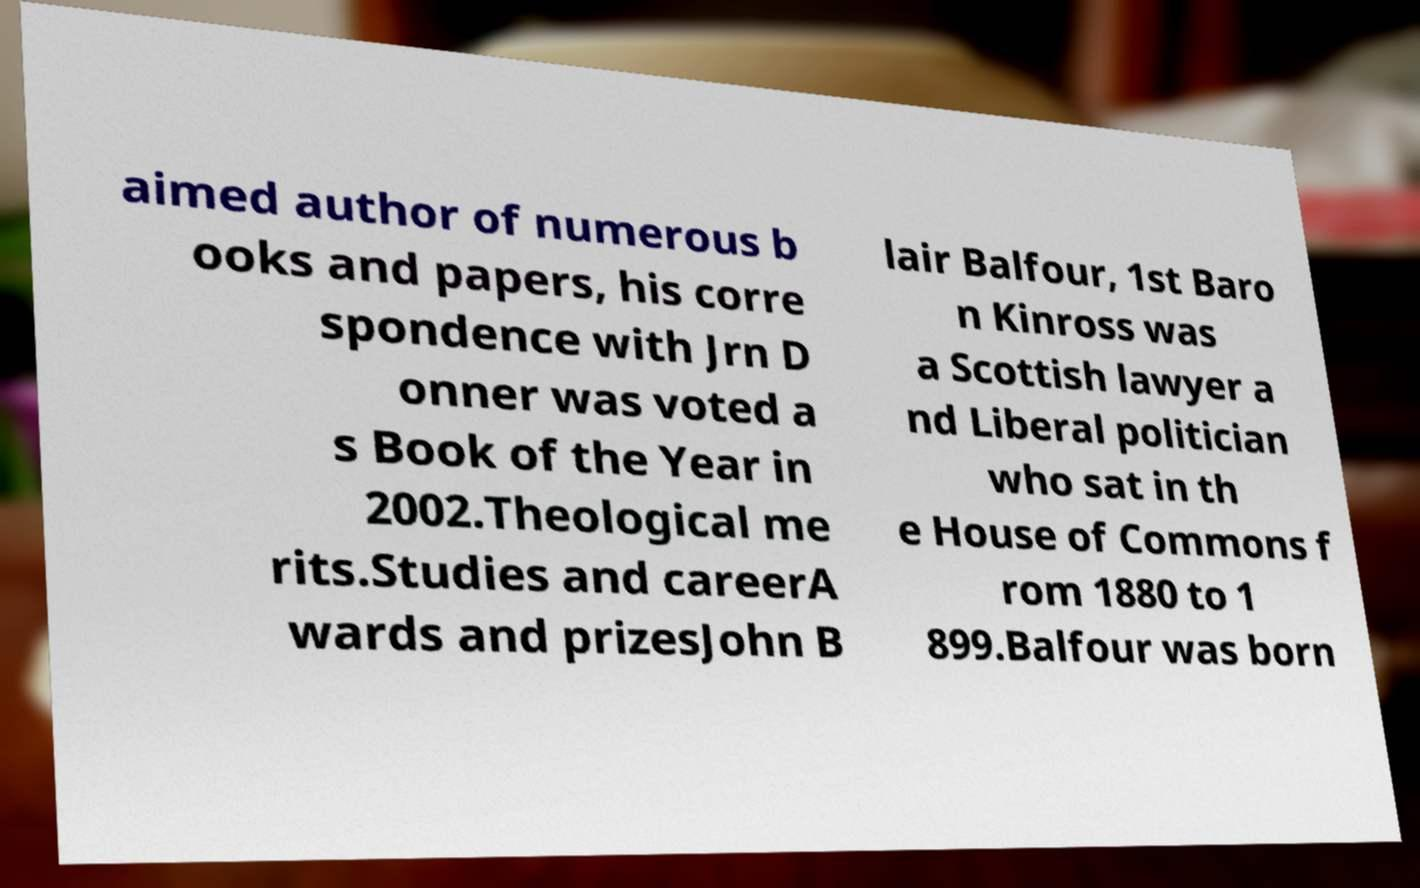For documentation purposes, I need the text within this image transcribed. Could you provide that? aimed author of numerous b ooks and papers, his corre spondence with Jrn D onner was voted a s Book of the Year in 2002.Theological me rits.Studies and careerA wards and prizesJohn B lair Balfour, 1st Baro n Kinross was a Scottish lawyer a nd Liberal politician who sat in th e House of Commons f rom 1880 to 1 899.Balfour was born 